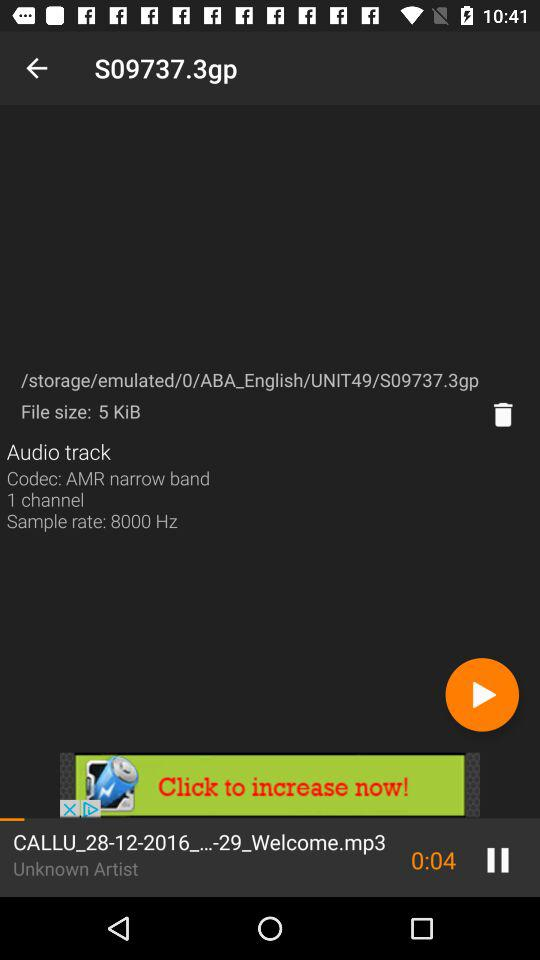What is the codec of the audio track? The codec of the audio track is "AMR narrow band 1 channel". 